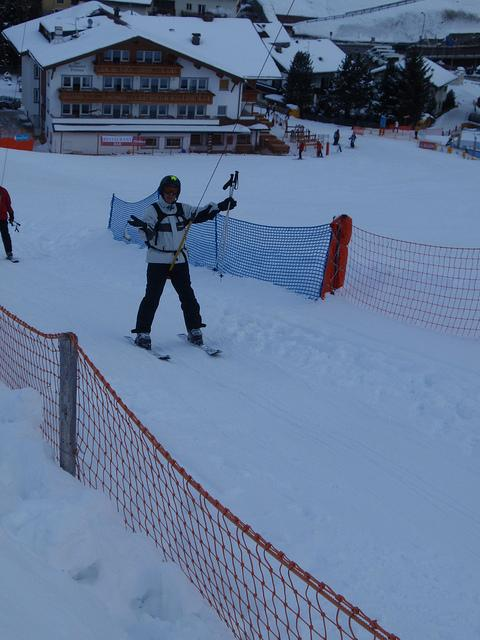What's the name of the large white building in the background? Please explain your reasoning. lodge. A person is on a snowy hill skiing with a large building in the background. 